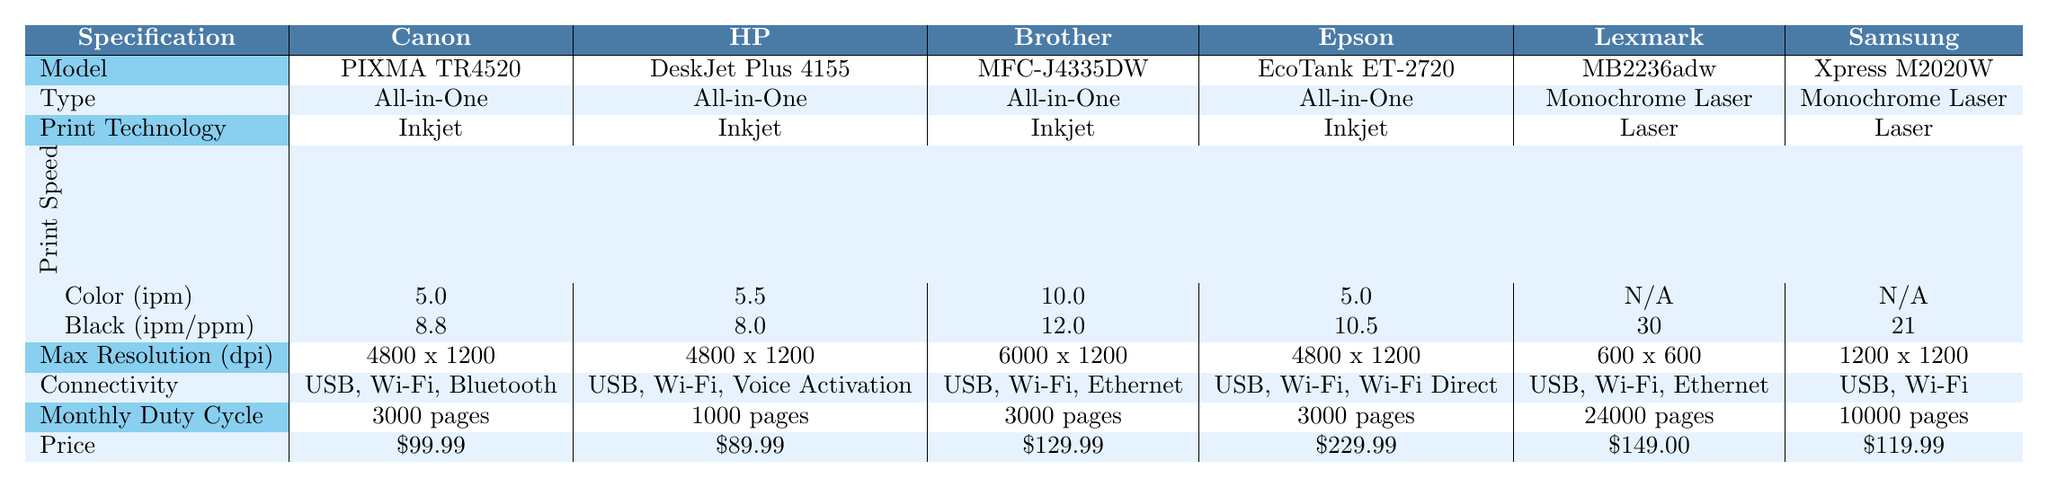What is the price of the HP DeskJet Plus 4155? The table lists "Price" for each printer model. The HP DeskJet Plus 4155 is listed with a price of $89.99.
Answer: $89.99 Which printer has the highest print speed for color? By comparing the "Print Speed (Color)" values for each printer, the Brother MFC-J4335DW has the highest speed at 10.0 ipm.
Answer: Brother MFC-J4335DW Is the Canon PIXMA TR4520 an All-in-One printer? Looking at the "Type" row, the Canon PIXMA TR4520 is categorized as "All-in-One."
Answer: Yes What is the difference in monthly duty cycle between Lexmark MB2236adw and HP DeskJet Plus 4155? The Lexmark MB2236adw has a monthly duty cycle of 24,000 pages, while the HP DeskJet Plus 4155 has 1,000 pages. The difference is 24,000 - 1,000 = 23,000 pages.
Answer: 23,000 pages What is the maximum resolution of the Brother MFC-J4335DW? The "Max Resolution" row shows that the Brother MFC-J4335DW has a maximum resolution of 6000 x 1200 dpi.
Answer: 6000 x 1200 dpi Which printer has the lowest price and what is it? The table provides the prices of all printers, and the HP DeskJet Plus 4155 has the lowest price at $89.99.
Answer: $89.99 How many printers have a monthly duty cycle of over 3000 pages? Reviewing the "Monthly Duty Cycle," the Lexmark MB2236adw has 24,000 pages, and the Samsung Xpress M2020W has 10,000 pages. Therefore, there are 2 printers with a duty cycle over 3000 pages.
Answer: 2 What is the average print speed for black ink across all the All-in-One printers? First, we find the black print speeds for the All-in-One printers: 8.8, 8.0, 12.0, and 10.5. The sum is 8.8 + 8.0 + 12.0 + 10.5 = 39.3. Then we divide by the number of All-in-One printers, which is 4. The average is 39.3 / 4 = 9.825 ipm.
Answer: 9.83 ipm Does the Epson EcoTank ET-2720 have Bluetooth connectivity? Checking the "Connectivity" for the Epson EcoTank ET-2720, it lists USB, Wi-Fi, and Wi-Fi Direct, but not Bluetooth.
Answer: No Which printer has the highest max resolution and what is it? The max resolutions are compared, and the Brother MFC-J4335DW has the highest resolution at 6000 x 1200 dpi.
Answer: 6000 x 1200 dpi 